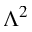<formula> <loc_0><loc_0><loc_500><loc_500>\Lambda ^ { 2 }</formula> 